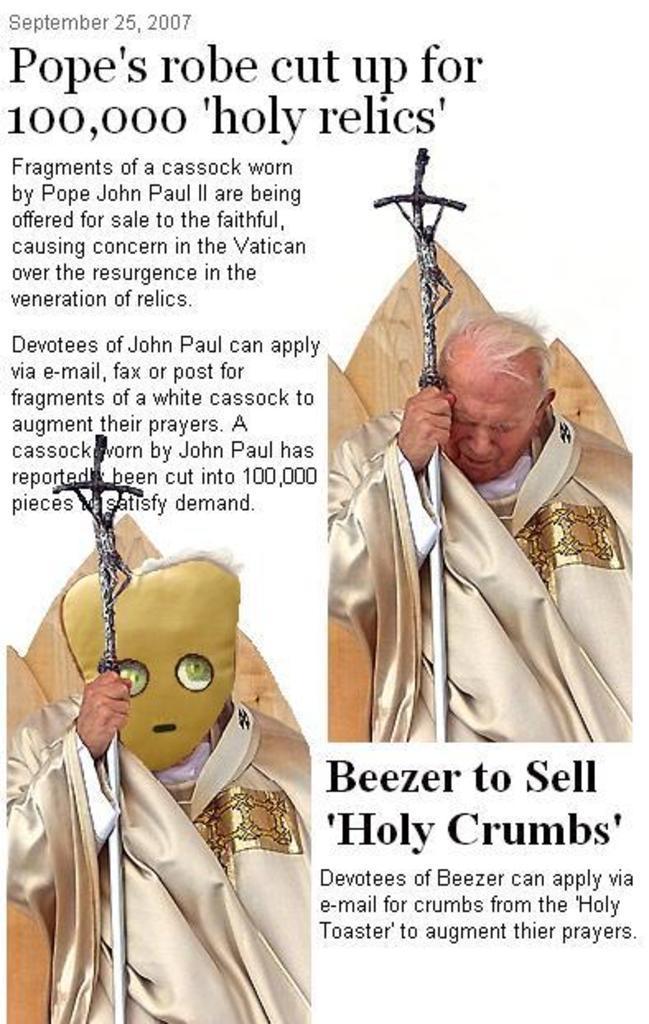Please provide a concise description of this image. In this image we can see a man is standing, and holding an iron rod in the hands, here is the matter written on it. 